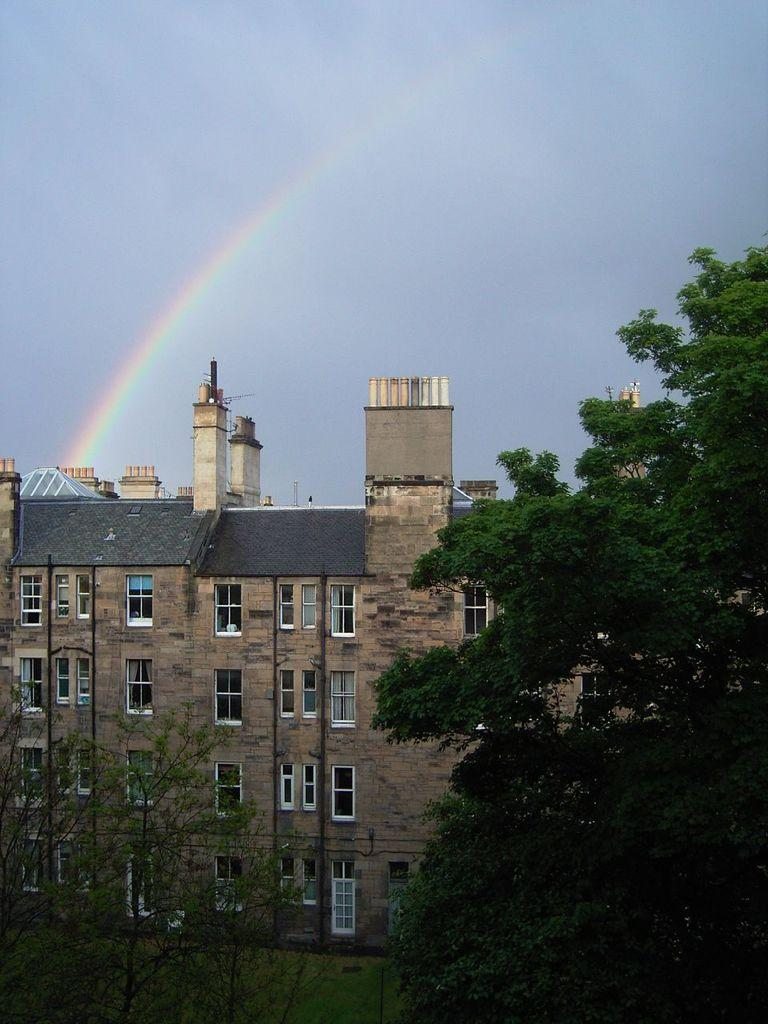What type of structure can be seen in the image? There is a building in the image. What other natural elements are present in the image? There are trees in the image. What is visible at the top of the image? The sky is visible at the top of the image. What additional feature can be observed in the sky? There is a rainbow in the image. What type of brass instrument is being played by the trees in the image? There is no brass instrument or trees playing an instrument in the image. Can you describe the swimming pool near the building in the image? There is no swimming pool present in the image. 